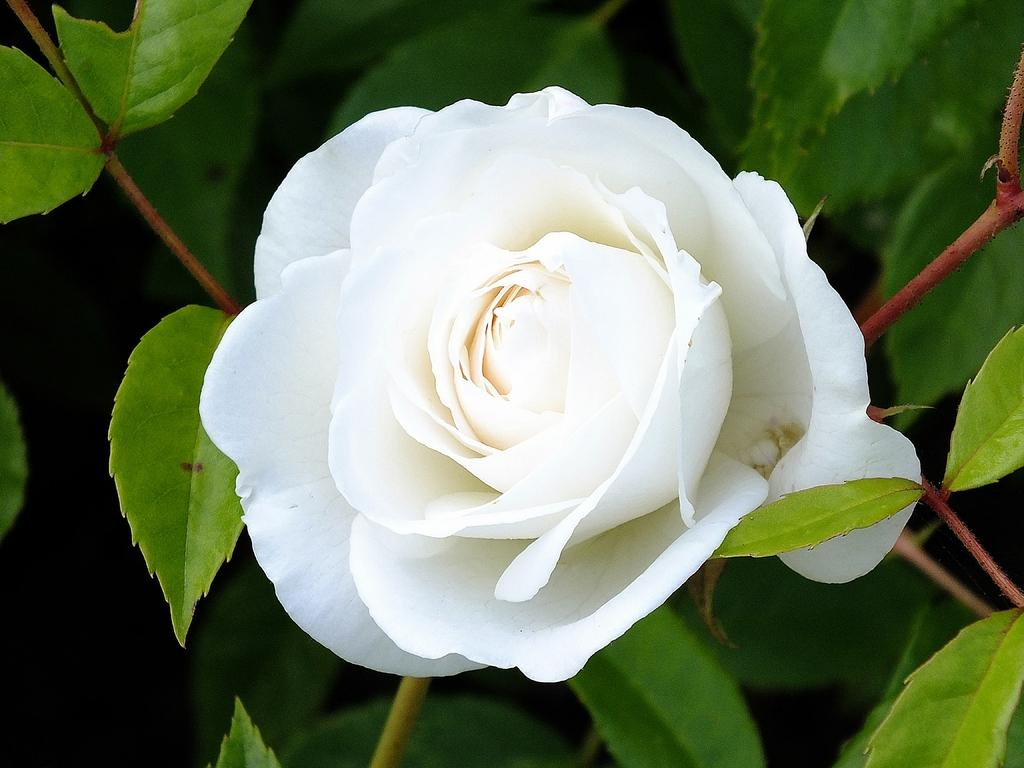What type of flower is in the picture? There is a white rose flower in the picture. What are the main features of the flower? The flower has petals. Is the flower part of a larger plant? Yes, the flower is attached to a plant. What other parts of the plant can be seen in the picture? There are leaves in the picture. What type of trains can be seen passing through the cemetery in the image? There are no trains or cemeteries present in the image; it features a white rose flower with petals and leaves. 